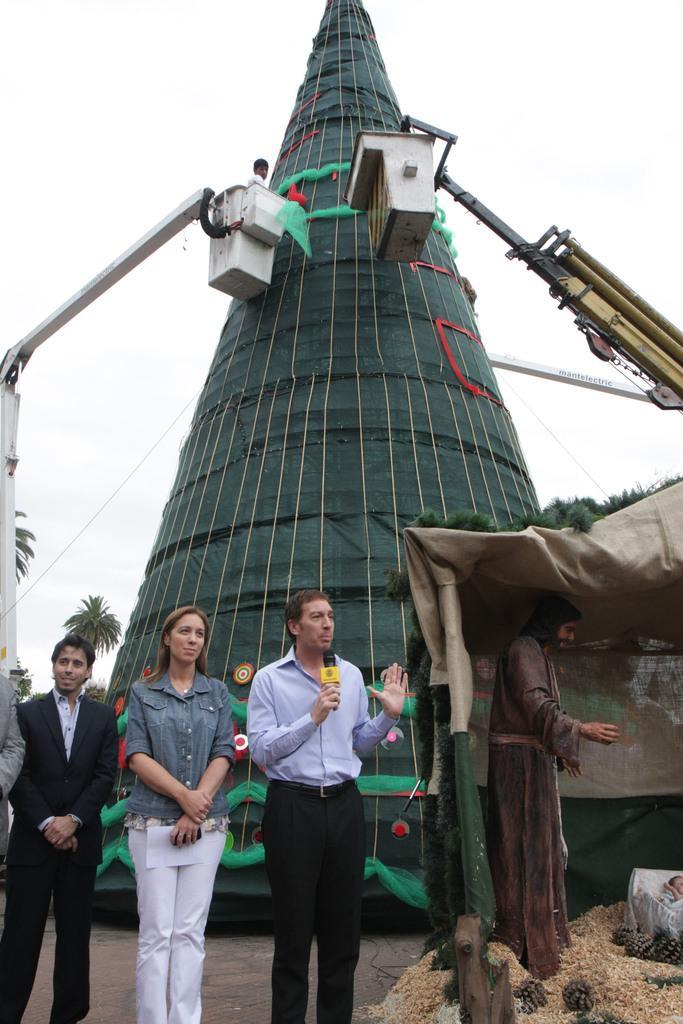Describe this image in one or two sentences. This image is taken indoors. At the top of the image there is the sky. In the background there is an artificial Christmas tree and there are few trees. There are two poles in the baskets and there is a person in the basket. In the middle of the image a woman and three men are standing on the ground and a man is holding a mic in his hand. On the right side of the image there is a hut and there are a few toys in the hut. 